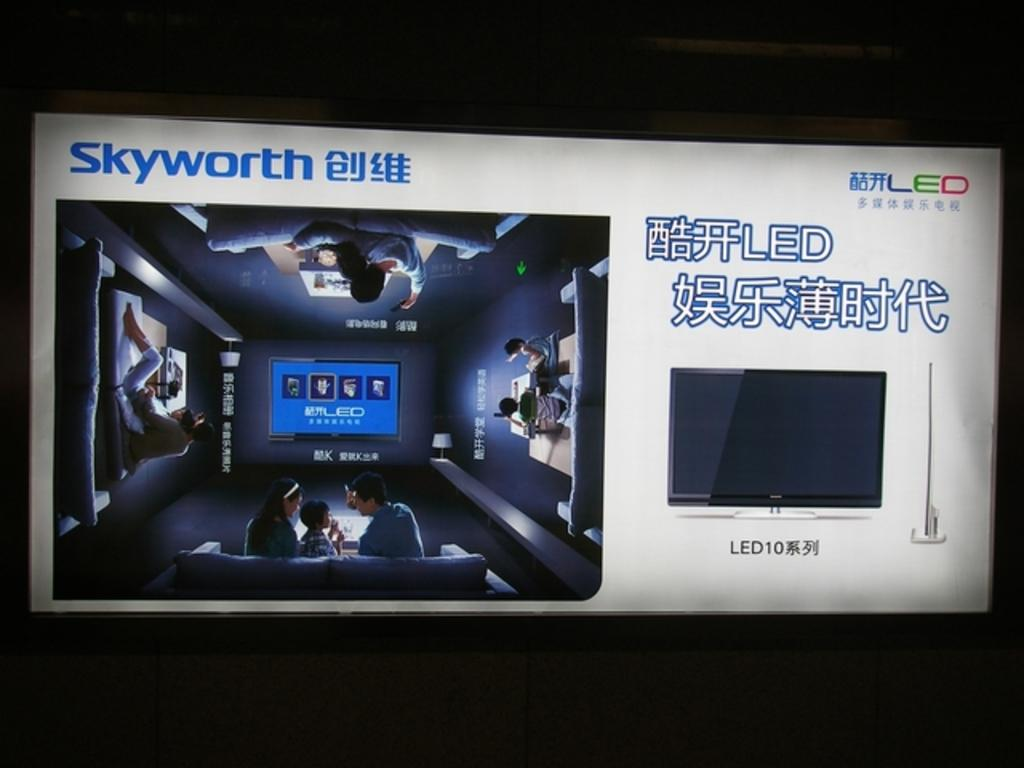Provide a one-sentence caption for the provided image. An ad for a Skyworth LED TV shows a family sitting in their home theater. 